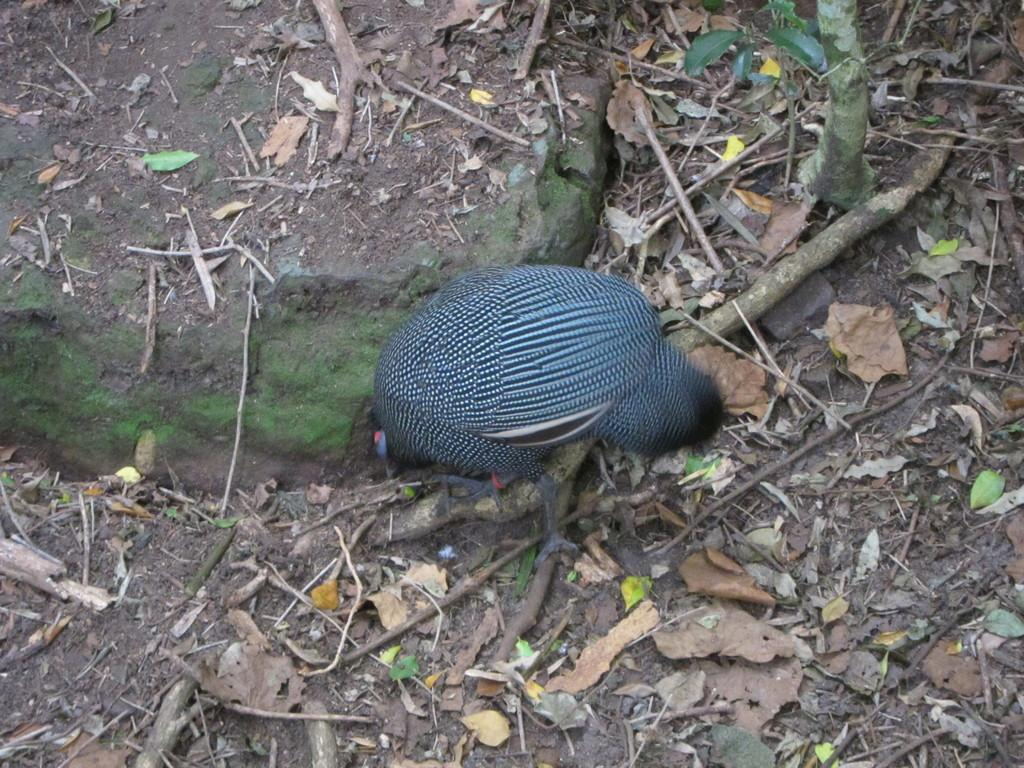What type of animal is in the image? There is a Phasianidae (a type of bird) in the image. Where is the Phasianidae located in the image? The Phasianidae is present on the ground. What else can be seen on the ground in the image? Dry leaves and stems of a tree are present on the ground. What type of crime is being committed by the Phasianidae in the image? There is no crime being committed by the Phasianidae in the image; it is simply a bird present on the ground. 